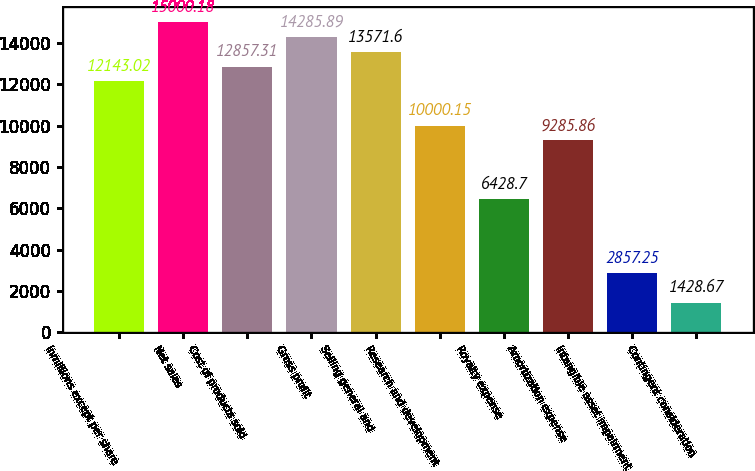<chart> <loc_0><loc_0><loc_500><loc_500><bar_chart><fcel>inmillions except per share<fcel>Net sales<fcel>Cost of products sold<fcel>Gross profit<fcel>Selling general and<fcel>Research and development<fcel>Royalty expense<fcel>Amortization expense<fcel>Intangible asset impairment<fcel>Contingent consideration<nl><fcel>12143<fcel>15000.2<fcel>12857.3<fcel>14285.9<fcel>13571.6<fcel>10000.1<fcel>6428.7<fcel>9285.86<fcel>2857.25<fcel>1428.67<nl></chart> 